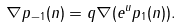Convert formula to latex. <formula><loc_0><loc_0><loc_500><loc_500>\nabla p _ { - 1 } ( n ) = q \nabla ( e ^ { u } p _ { 1 } ( n ) ) .</formula> 